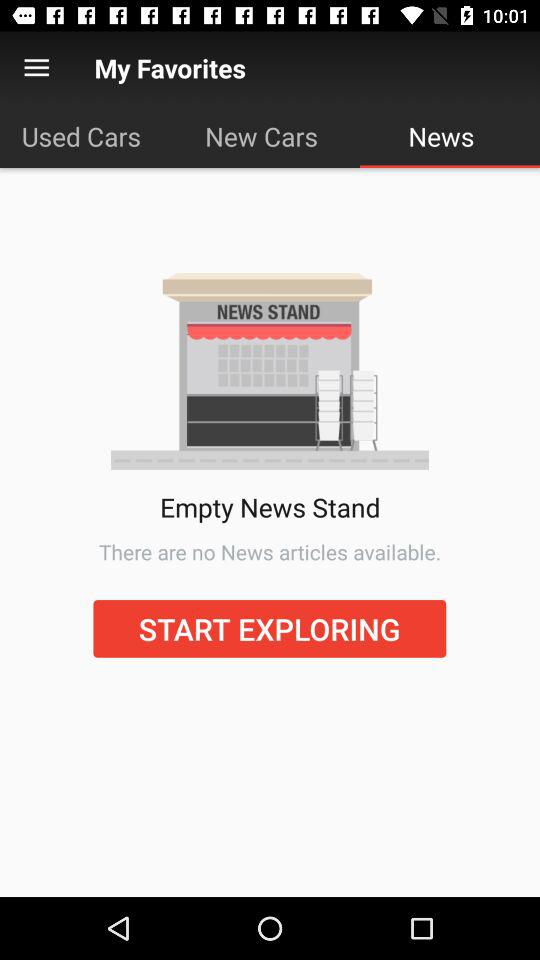Which tab am I on? You are on the "News" tab. 